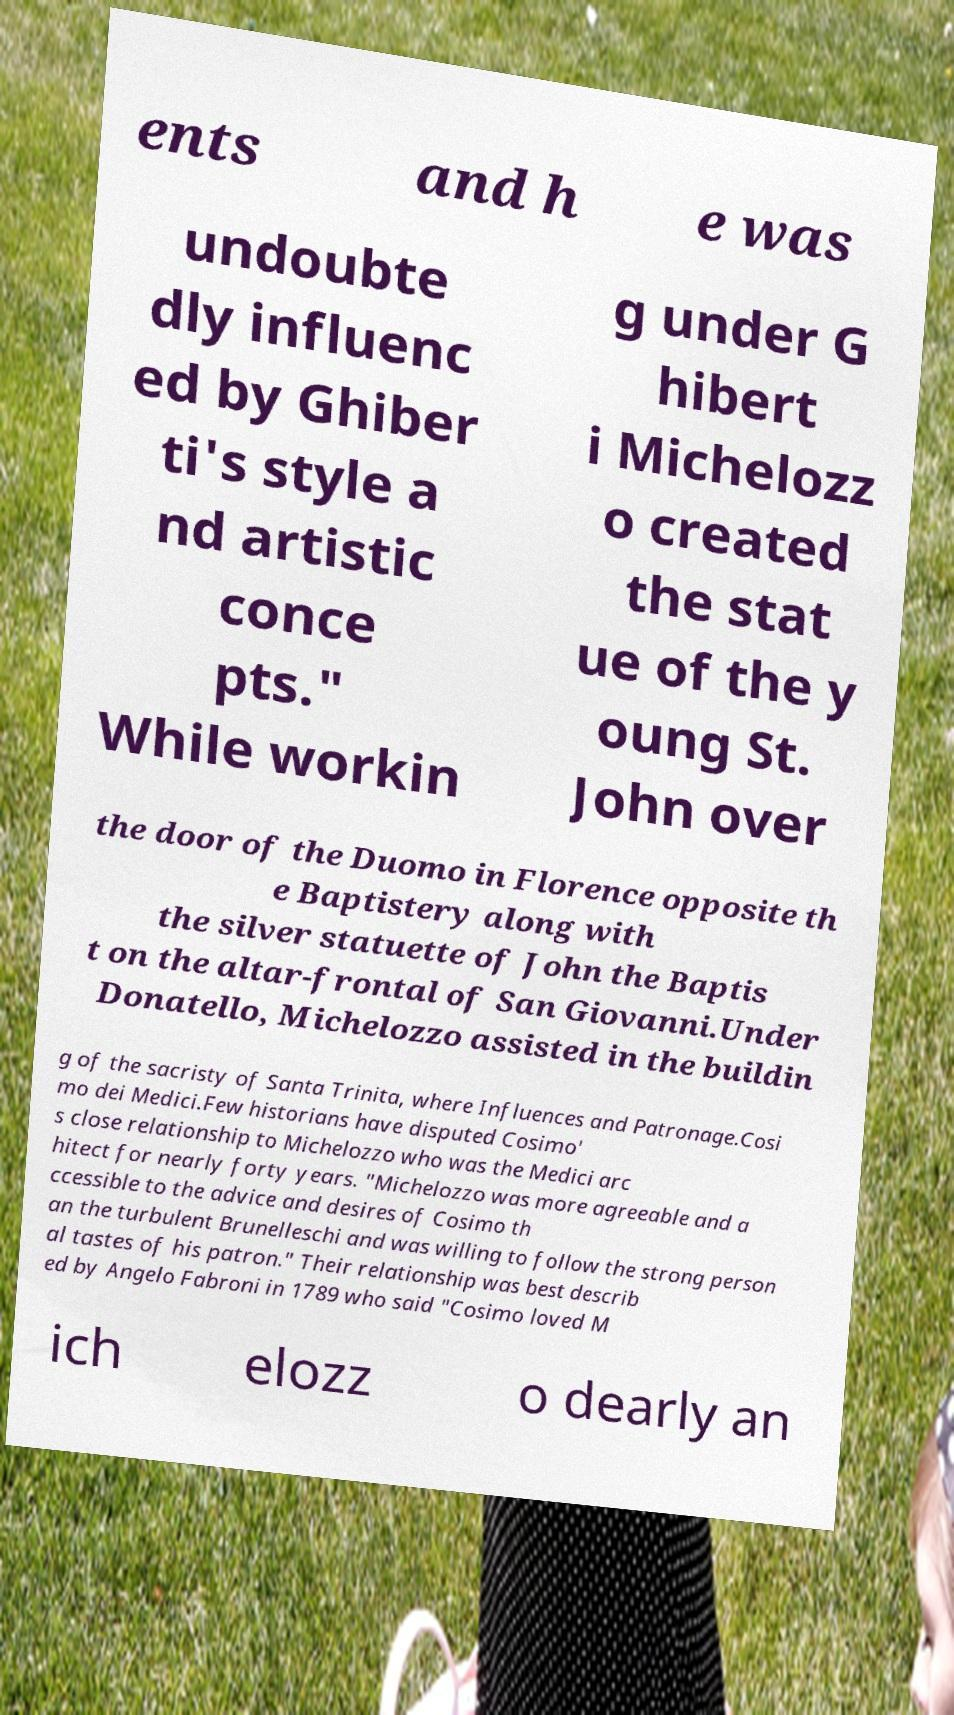Could you assist in decoding the text presented in this image and type it out clearly? ents and h e was undoubte dly influenc ed by Ghiber ti's style a nd artistic conce pts." While workin g under G hibert i Michelozz o created the stat ue of the y oung St. John over the door of the Duomo in Florence opposite th e Baptistery along with the silver statuette of John the Baptis t on the altar-frontal of San Giovanni.Under Donatello, Michelozzo assisted in the buildin g of the sacristy of Santa Trinita, where Influences and Patronage.Cosi mo dei Medici.Few historians have disputed Cosimo' s close relationship to Michelozzo who was the Medici arc hitect for nearly forty years. "Michelozzo was more agreeable and a ccessible to the advice and desires of Cosimo th an the turbulent Brunelleschi and was willing to follow the strong person al tastes of his patron." Their relationship was best describ ed by Angelo Fabroni in 1789 who said "Cosimo loved M ich elozz o dearly an 